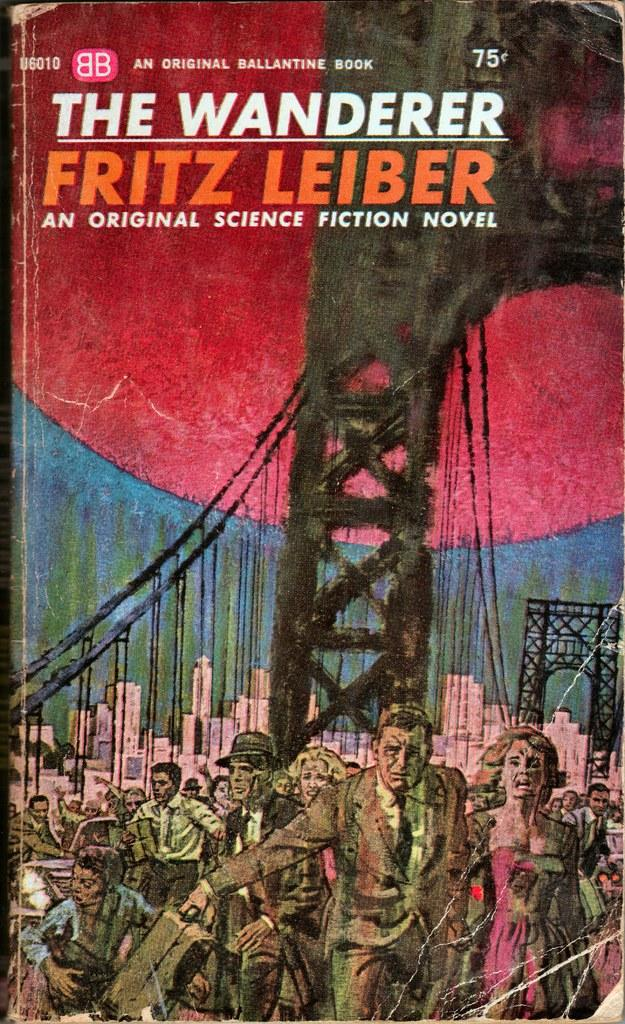<image>
Give a short and clear explanation of the subsequent image. the wanderer book is a science fiction novel with an image of a burning bridge on it 